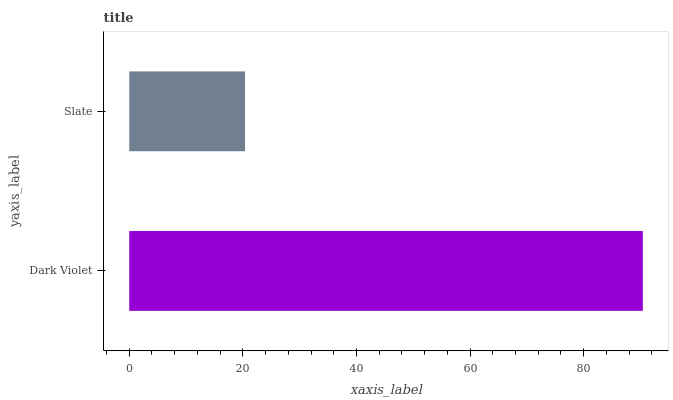Is Slate the minimum?
Answer yes or no. Yes. Is Dark Violet the maximum?
Answer yes or no. Yes. Is Slate the maximum?
Answer yes or no. No. Is Dark Violet greater than Slate?
Answer yes or no. Yes. Is Slate less than Dark Violet?
Answer yes or no. Yes. Is Slate greater than Dark Violet?
Answer yes or no. No. Is Dark Violet less than Slate?
Answer yes or no. No. Is Dark Violet the high median?
Answer yes or no. Yes. Is Slate the low median?
Answer yes or no. Yes. Is Slate the high median?
Answer yes or no. No. Is Dark Violet the low median?
Answer yes or no. No. 